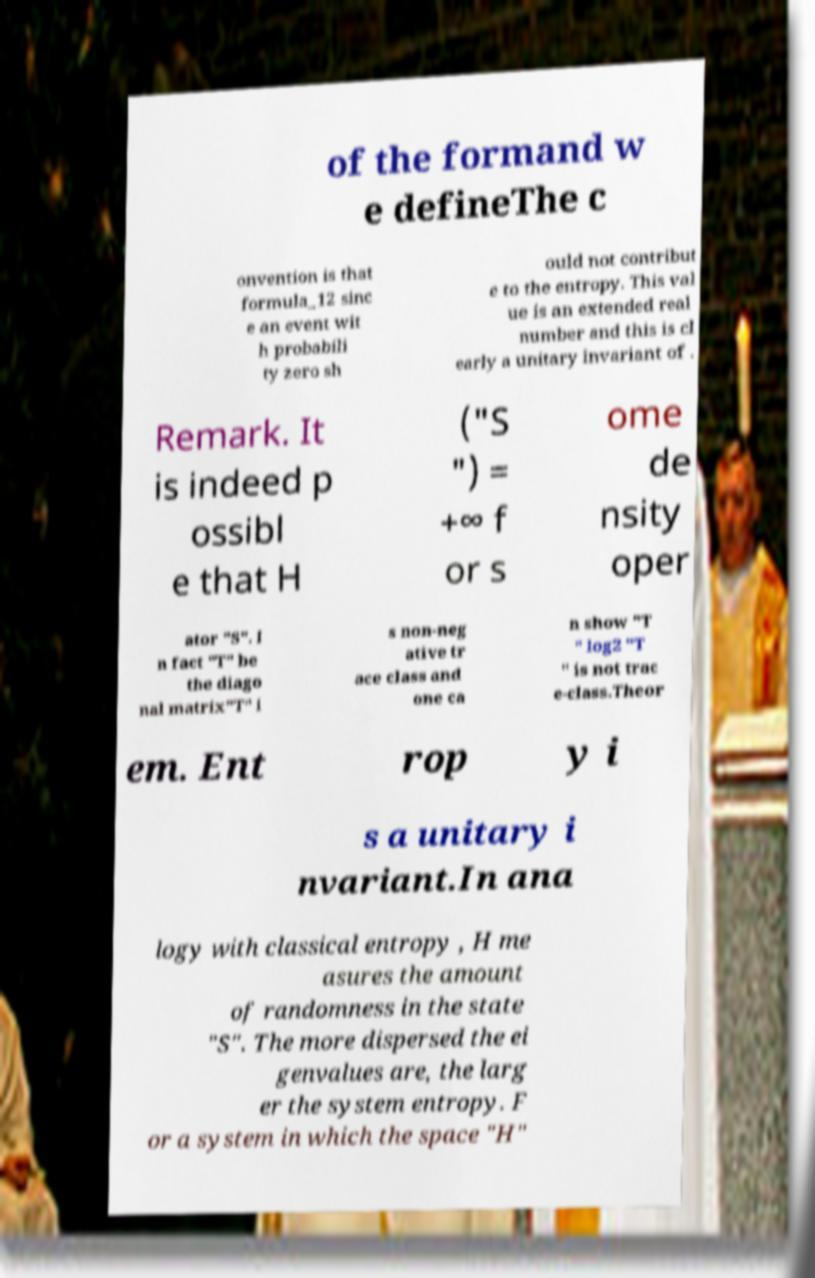I need the written content from this picture converted into text. Can you do that? of the formand w e defineThe c onvention is that formula_12 sinc e an event wit h probabili ty zero sh ould not contribut e to the entropy. This val ue is an extended real number and this is cl early a unitary invariant of . Remark. It is indeed p ossibl e that H ("S ") = +∞ f or s ome de nsity oper ator "S". I n fact "T" be the diago nal matrix"T" i s non-neg ative tr ace class and one ca n show "T " log2 "T " is not trac e-class.Theor em. Ent rop y i s a unitary i nvariant.In ana logy with classical entropy , H me asures the amount of randomness in the state "S". The more dispersed the ei genvalues are, the larg er the system entropy. F or a system in which the space "H" 